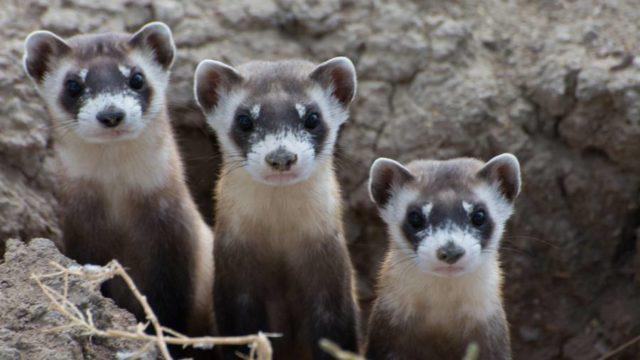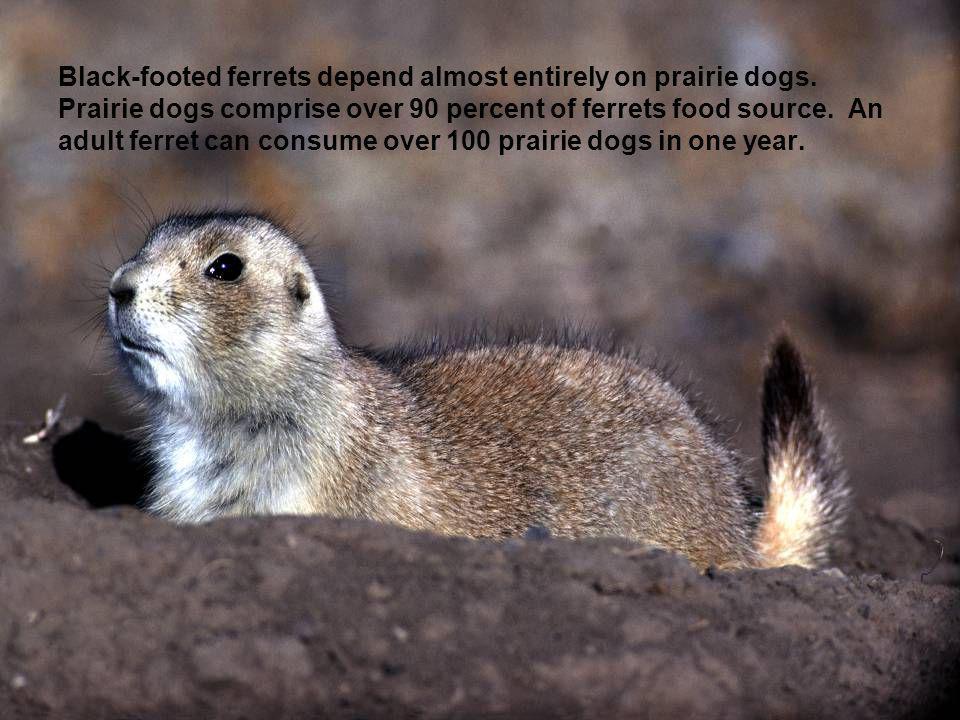The first image is the image on the left, the second image is the image on the right. For the images shown, is this caption "There are two black footed ferrets standing outside in the center of the image." true? Answer yes or no. No. The first image is the image on the left, the second image is the image on the right. For the images displayed, is the sentence "There Is a single brown and white small rodent facing left with black nose." factually correct? Answer yes or no. Yes. 